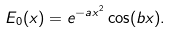<formula> <loc_0><loc_0><loc_500><loc_500>E _ { 0 } ( x ) = e ^ { - a x ^ { 2 } } \cos ( b x ) .</formula> 